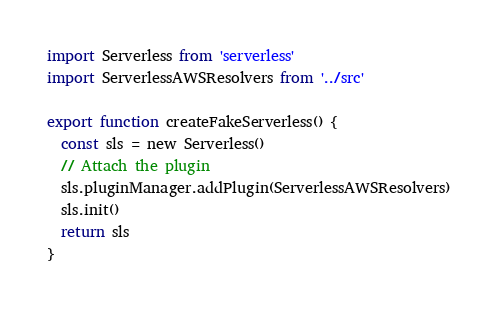<code> <loc_0><loc_0><loc_500><loc_500><_JavaScript_>import Serverless from 'serverless'
import ServerlessAWSResolvers from '../src'

export function createFakeServerless() {
  const sls = new Serverless()
  // Attach the plugin
  sls.pluginManager.addPlugin(ServerlessAWSResolvers)
  sls.init()
  return sls
}
</code> 